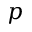Convert formula to latex. <formula><loc_0><loc_0><loc_500><loc_500>p</formula> 